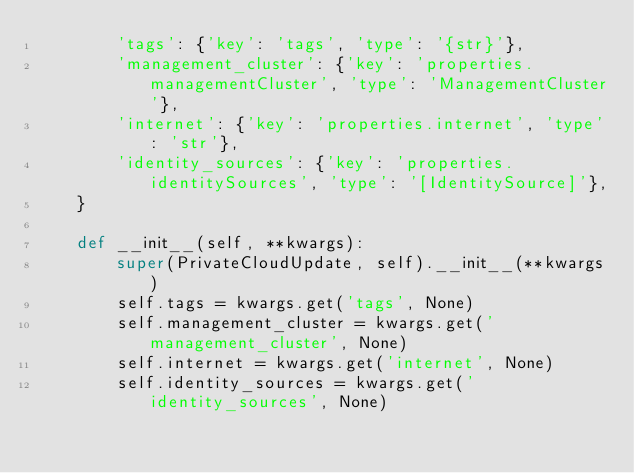<code> <loc_0><loc_0><loc_500><loc_500><_Python_>        'tags': {'key': 'tags', 'type': '{str}'},
        'management_cluster': {'key': 'properties.managementCluster', 'type': 'ManagementCluster'},
        'internet': {'key': 'properties.internet', 'type': 'str'},
        'identity_sources': {'key': 'properties.identitySources', 'type': '[IdentitySource]'},
    }

    def __init__(self, **kwargs):
        super(PrivateCloudUpdate, self).__init__(**kwargs)
        self.tags = kwargs.get('tags', None)
        self.management_cluster = kwargs.get('management_cluster', None)
        self.internet = kwargs.get('internet', None)
        self.identity_sources = kwargs.get('identity_sources', None)
</code> 